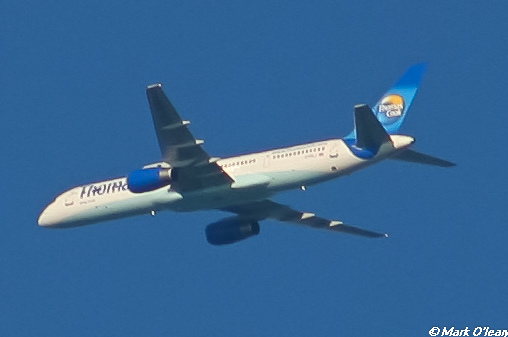Read and extract the text from this image. O'lean Mart 